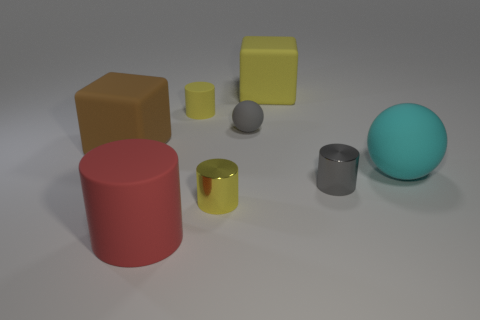Are there fewer large red cylinders that are on the right side of the yellow metallic cylinder than tiny cylinders on the right side of the yellow block?
Give a very brief answer. Yes. What is the color of the large rubber thing that is in front of the tiny matte cylinder and right of the red rubber cylinder?
Provide a short and direct response. Cyan. Is the size of the red rubber cylinder the same as the yellow rubber object that is on the right side of the tiny gray matte thing?
Offer a terse response. Yes. What is the shape of the small metallic thing to the right of the yellow shiny thing?
Offer a very short reply. Cylinder. Are there more metallic things that are behind the large matte cylinder than big yellow matte objects?
Give a very brief answer. Yes. What number of tiny gray objects are to the left of the big matte cube that is behind the rubber ball that is behind the big cyan rubber object?
Your answer should be very brief. 1. There is a rubber cube behind the large brown matte object; does it have the same size as the metal object to the left of the large yellow rubber cube?
Your answer should be very brief. No. What is the material of the cylinder that is on the right side of the gray object left of the tiny gray cylinder?
Provide a short and direct response. Metal. What number of objects are either objects to the left of the big ball or tiny brown rubber blocks?
Ensure brevity in your answer.  7. Are there the same number of matte balls to the left of the small gray rubber sphere and small spheres behind the yellow shiny object?
Ensure brevity in your answer.  No. 